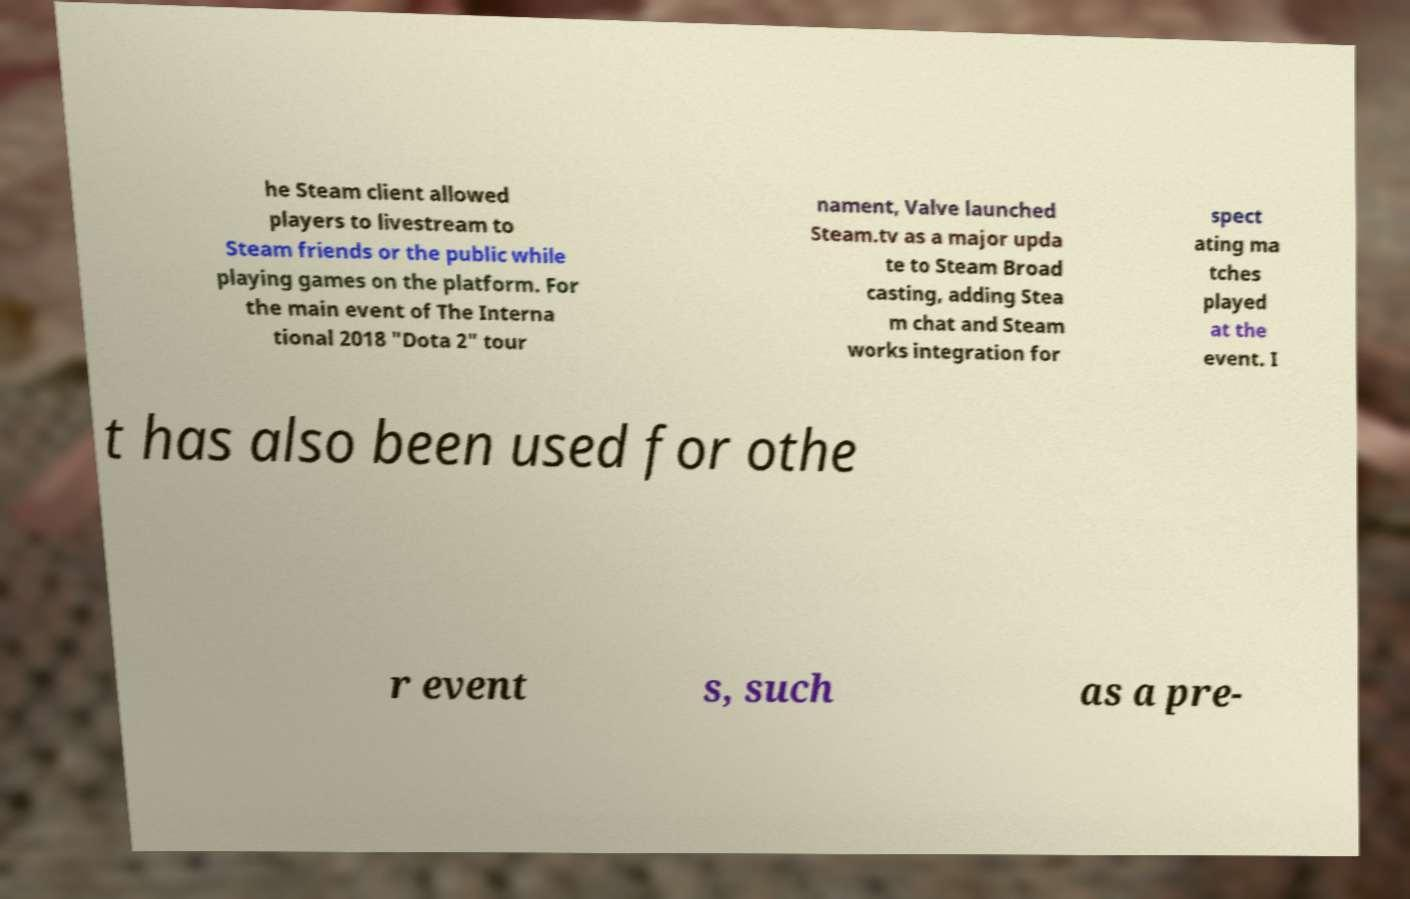What messages or text are displayed in this image? I need them in a readable, typed format. he Steam client allowed players to livestream to Steam friends or the public while playing games on the platform. For the main event of The Interna tional 2018 "Dota 2" tour nament, Valve launched Steam.tv as a major upda te to Steam Broad casting, adding Stea m chat and Steam works integration for spect ating ma tches played at the event. I t has also been used for othe r event s, such as a pre- 